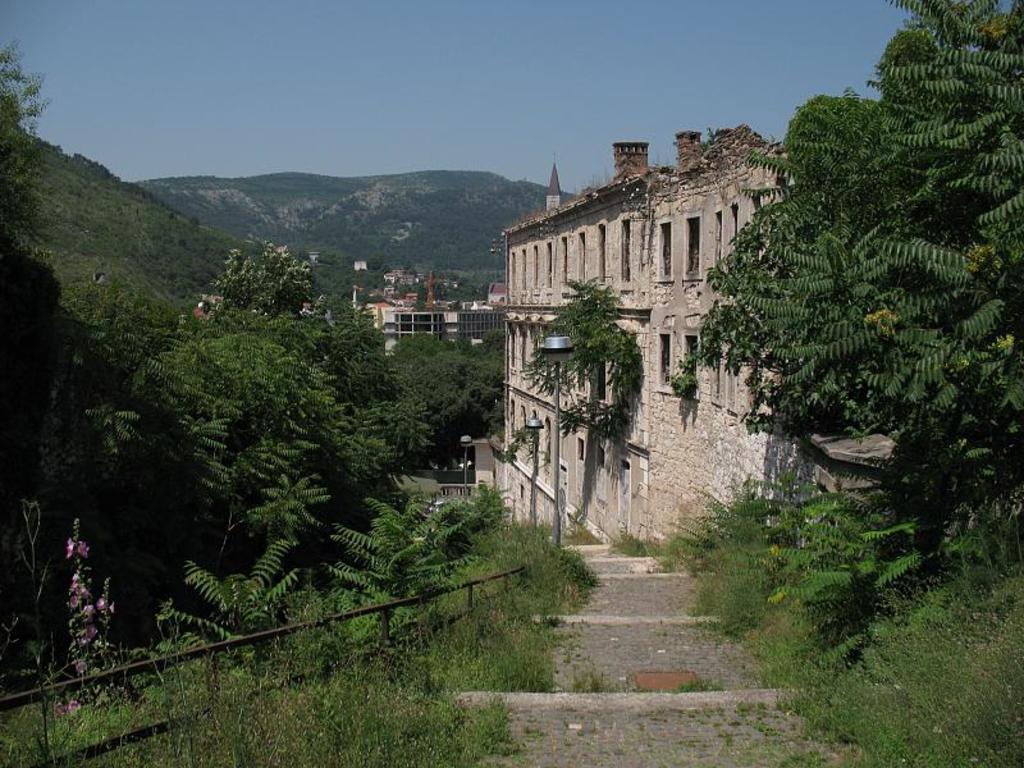Describe this image in one or two sentences. In this picture we can see few trees, buildings, poles and lights, in the background we can find hills. 